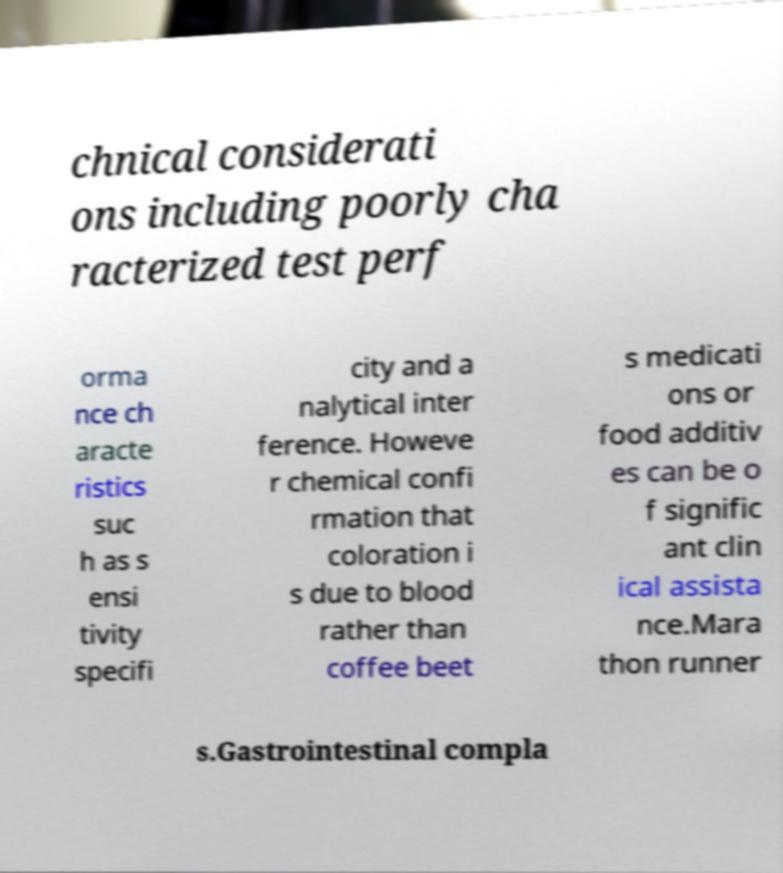Can you read and provide the text displayed in the image?This photo seems to have some interesting text. Can you extract and type it out for me? chnical considerati ons including poorly cha racterized test perf orma nce ch aracte ristics suc h as s ensi tivity specifi city and a nalytical inter ference. Howeve r chemical confi rmation that coloration i s due to blood rather than coffee beet s medicati ons or food additiv es can be o f signific ant clin ical assista nce.Mara thon runner s.Gastrointestinal compla 